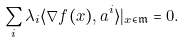Convert formula to latex. <formula><loc_0><loc_0><loc_500><loc_500>\sum _ { i } \lambda _ { i } \langle \nabla f ( x ) , a ^ { i } \rangle | _ { x \in \mathfrak m } = 0 .</formula> 